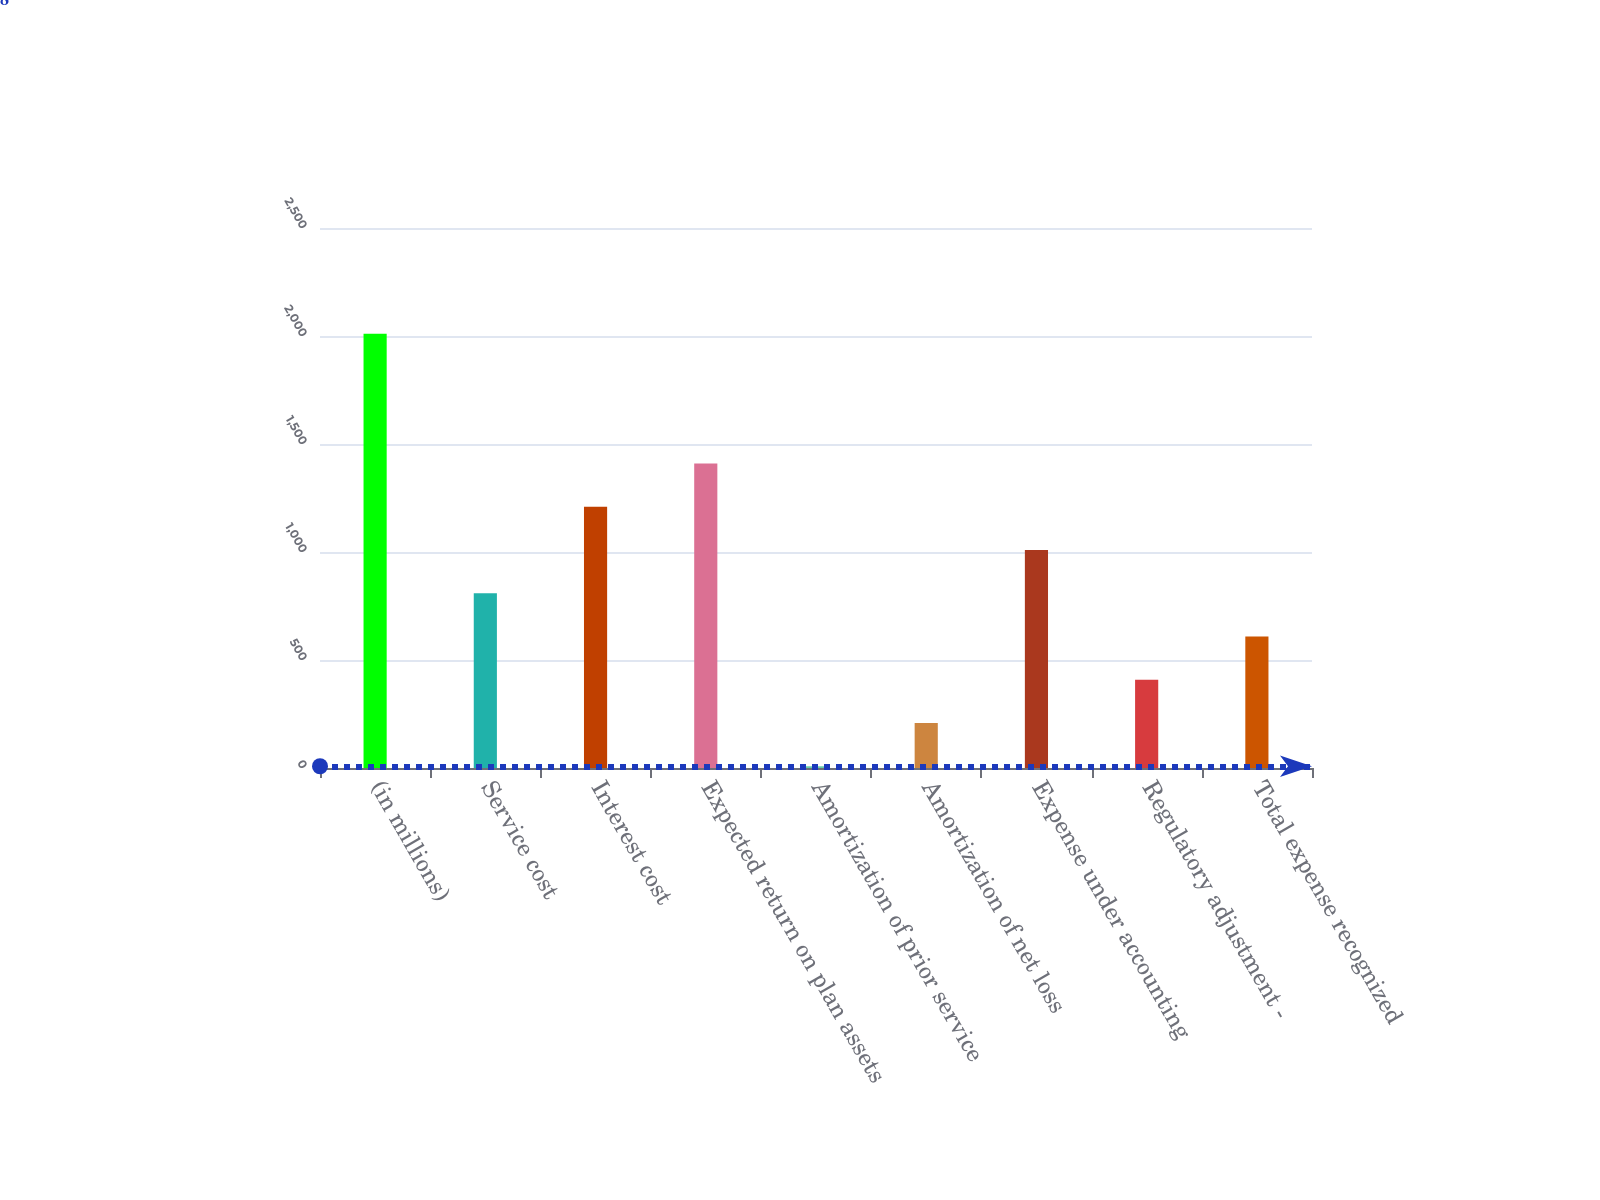Convert chart. <chart><loc_0><loc_0><loc_500><loc_500><bar_chart><fcel>(in millions)<fcel>Service cost<fcel>Interest cost<fcel>Expected return on plan assets<fcel>Amortization of prior service<fcel>Amortization of net loss<fcel>Expense under accounting<fcel>Regulatory adjustment -<fcel>Total expense recognized<nl><fcel>2010<fcel>808.8<fcel>1209.2<fcel>1409.4<fcel>8<fcel>208.2<fcel>1009<fcel>408.4<fcel>608.6<nl></chart> 